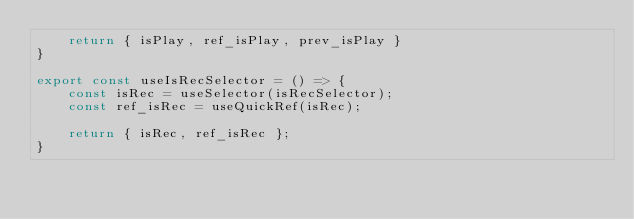Convert code to text. <code><loc_0><loc_0><loc_500><loc_500><_TypeScript_>    return { isPlay, ref_isPlay, prev_isPlay }
}

export const useIsRecSelector = () => {
    const isRec = useSelector(isRecSelector);
    const ref_isRec = useQuickRef(isRec);

    return { isRec, ref_isRec };
}</code> 